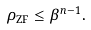Convert formula to latex. <formula><loc_0><loc_0><loc_500><loc_500>\rho _ { \text {ZF} } \leq \beta ^ { n - 1 } .</formula> 